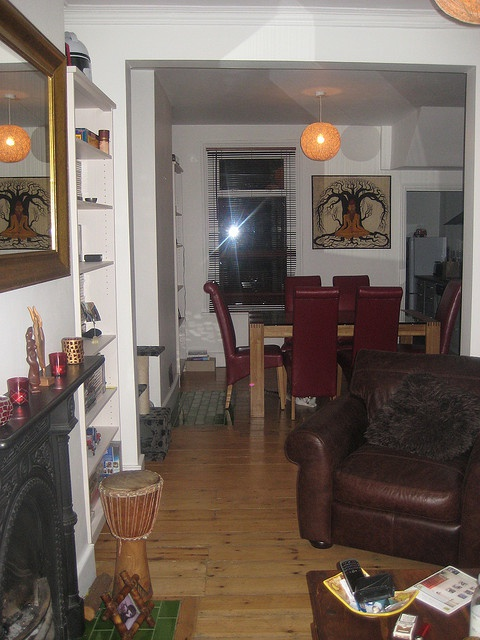Describe the objects in this image and their specific colors. I can see chair in black, maroon, and gray tones, chair in black, maroon, and brown tones, dining table in black, brown, gray, and maroon tones, chair in black, maroon, and gray tones, and chair in black, maroon, and brown tones in this image. 